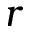<formula> <loc_0><loc_0><loc_500><loc_500>r</formula> 